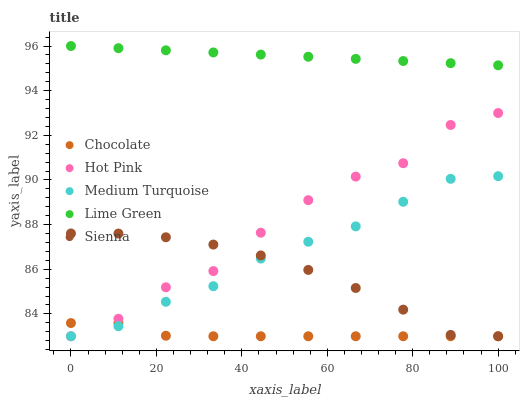Does Chocolate have the minimum area under the curve?
Answer yes or no. Yes. Does Lime Green have the maximum area under the curve?
Answer yes or no. Yes. Does Hot Pink have the minimum area under the curve?
Answer yes or no. No. Does Hot Pink have the maximum area under the curve?
Answer yes or no. No. Is Lime Green the smoothest?
Answer yes or no. Yes. Is Hot Pink the roughest?
Answer yes or no. Yes. Is Hot Pink the smoothest?
Answer yes or no. No. Is Lime Green the roughest?
Answer yes or no. No. Does Sienna have the lowest value?
Answer yes or no. Yes. Does Lime Green have the lowest value?
Answer yes or no. No. Does Lime Green have the highest value?
Answer yes or no. Yes. Does Hot Pink have the highest value?
Answer yes or no. No. Is Hot Pink less than Lime Green?
Answer yes or no. Yes. Is Lime Green greater than Medium Turquoise?
Answer yes or no. Yes. Does Sienna intersect Hot Pink?
Answer yes or no. Yes. Is Sienna less than Hot Pink?
Answer yes or no. No. Is Sienna greater than Hot Pink?
Answer yes or no. No. Does Hot Pink intersect Lime Green?
Answer yes or no. No. 